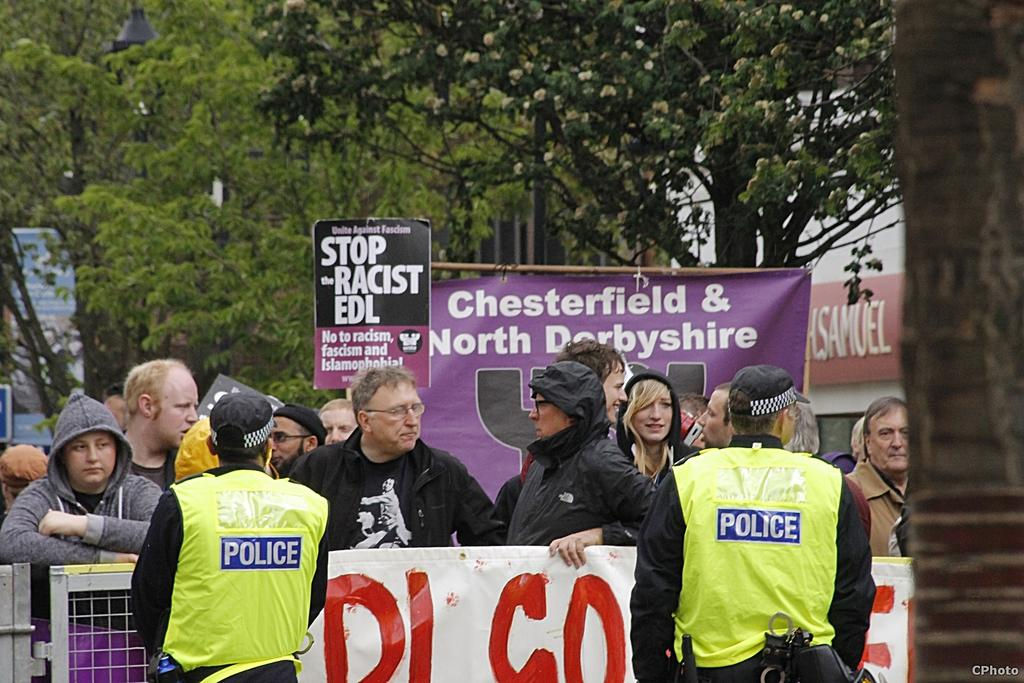What can be observed on the right side of the image? The right side of the image is blurred. What is the main focus of the image? There is a group of people, placards, barricades, a banner, and policemen in the center of the image. What is the background of the image composed of? There are trees and buildings in the background of the image. What type of credit card is being used by the person holding a calculator in the image? There is no person holding a calculator or using a credit card in the image. What flavor of cake is being served to the group of people in the image? There is no cake present in the image. 